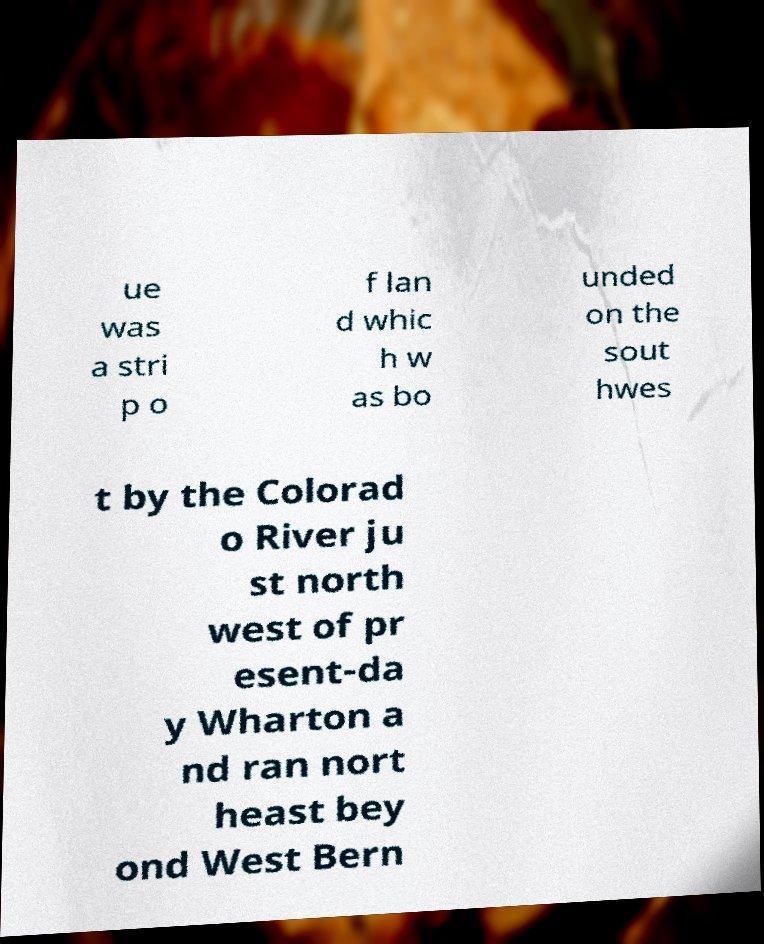Can you accurately transcribe the text from the provided image for me? ue was a stri p o f lan d whic h w as bo unded on the sout hwes t by the Colorad o River ju st north west of pr esent-da y Wharton a nd ran nort heast bey ond West Bern 